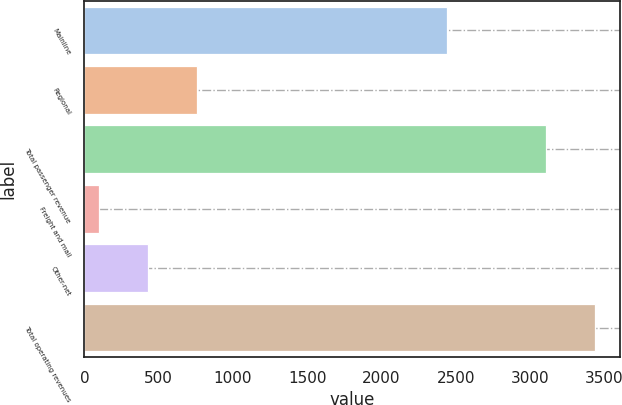Convert chart. <chart><loc_0><loc_0><loc_500><loc_500><bar_chart><fcel>Mainline<fcel>Regional<fcel>Total passenger revenue<fcel>Freight and mail<fcel>Other-net<fcel>Total operating revenues<nl><fcel>2438.8<fcel>756.68<fcel>3107.4<fcel>95.9<fcel>426.29<fcel>3437.79<nl></chart> 